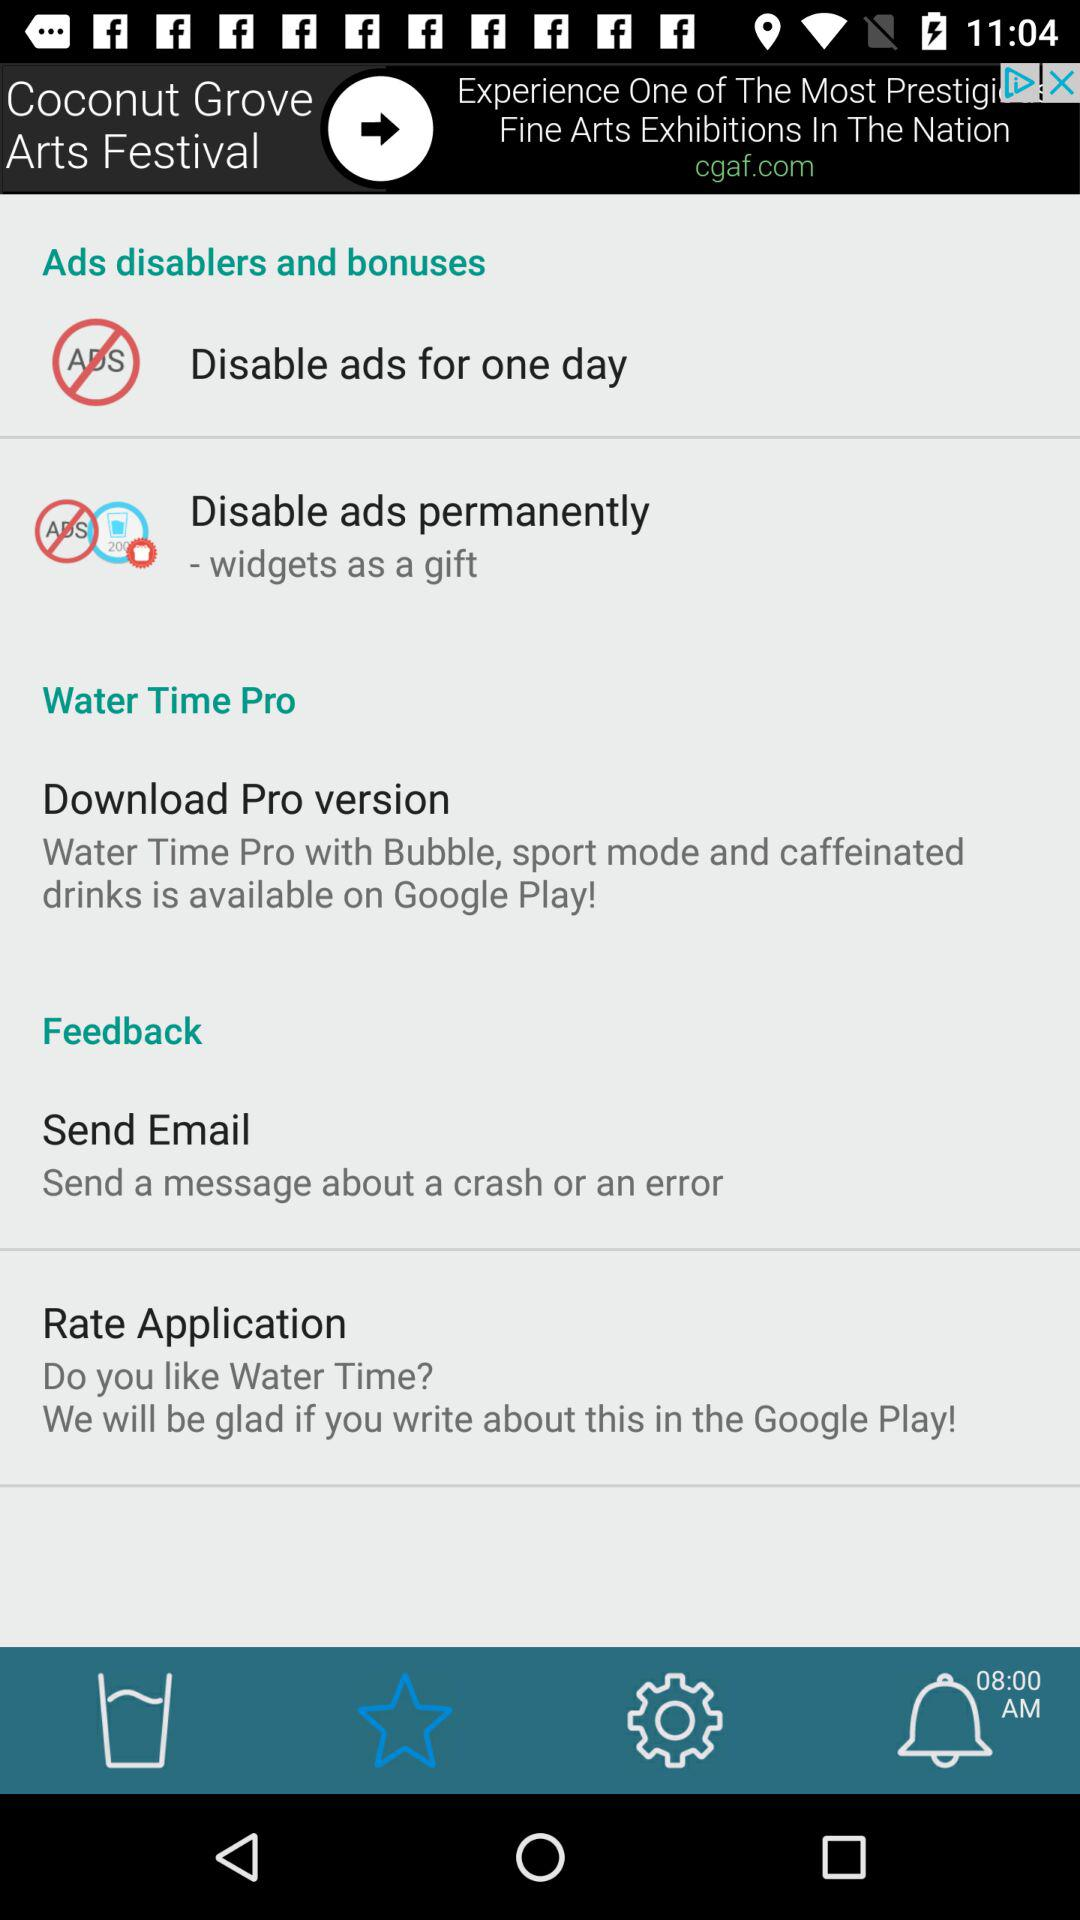What is the Download Pro version?
When the provided information is insufficient, respond with <no answer>. <no answer> 